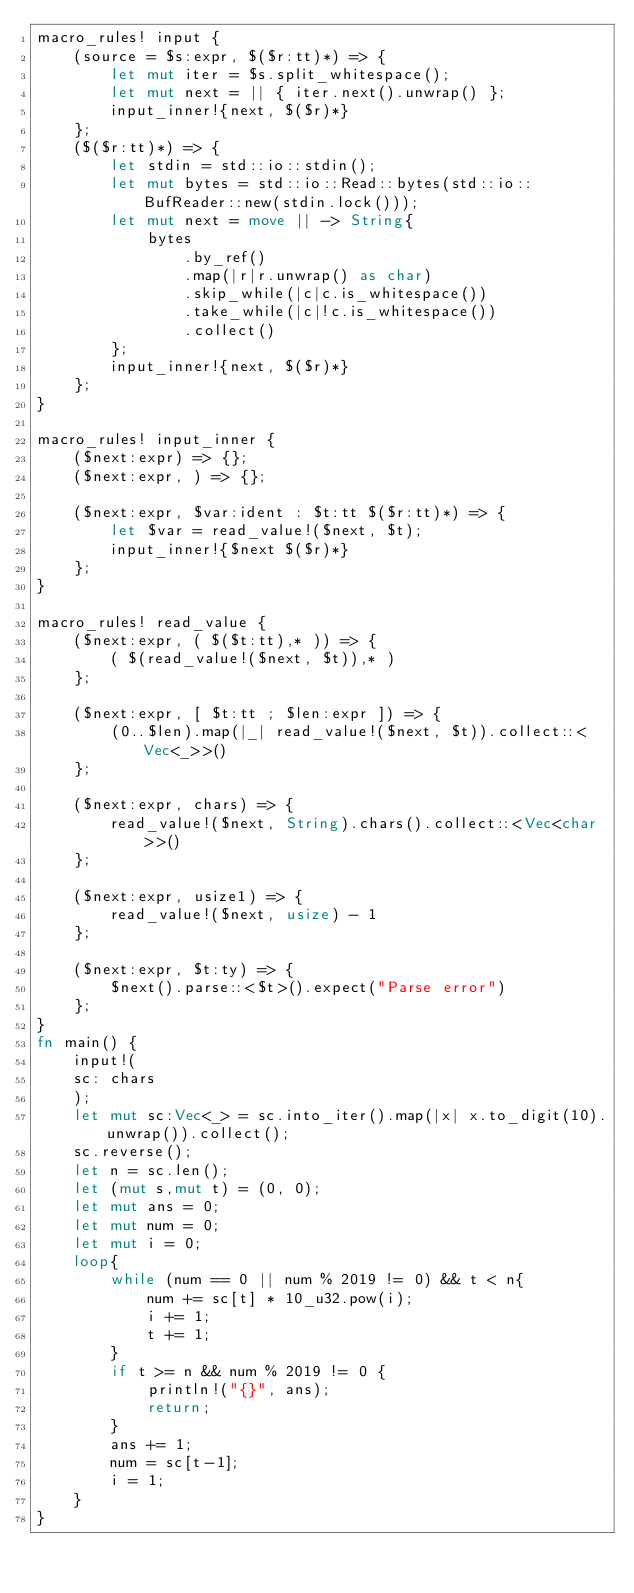Convert code to text. <code><loc_0><loc_0><loc_500><loc_500><_Rust_>macro_rules! input {
    (source = $s:expr, $($r:tt)*) => {
        let mut iter = $s.split_whitespace();
        let mut next = || { iter.next().unwrap() };
        input_inner!{next, $($r)*}
    };
    ($($r:tt)*) => {
        let stdin = std::io::stdin();
        let mut bytes = std::io::Read::bytes(std::io::BufReader::new(stdin.lock()));
        let mut next = move || -> String{
            bytes
                .by_ref()
                .map(|r|r.unwrap() as char)
                .skip_while(|c|c.is_whitespace())
                .take_while(|c|!c.is_whitespace())
                .collect()
        };
        input_inner!{next, $($r)*}
    };
}

macro_rules! input_inner {
    ($next:expr) => {};
    ($next:expr, ) => {};

    ($next:expr, $var:ident : $t:tt $($r:tt)*) => {
        let $var = read_value!($next, $t);
        input_inner!{$next $($r)*}
    };
}

macro_rules! read_value {
    ($next:expr, ( $($t:tt),* )) => {
        ( $(read_value!($next, $t)),* )
    };

    ($next:expr, [ $t:tt ; $len:expr ]) => {
        (0..$len).map(|_| read_value!($next, $t)).collect::<Vec<_>>()
    };

    ($next:expr, chars) => {
        read_value!($next, String).chars().collect::<Vec<char>>()
    };

    ($next:expr, usize1) => {
        read_value!($next, usize) - 1
    };

    ($next:expr, $t:ty) => {
        $next().parse::<$t>().expect("Parse error")
    };
}
fn main() {
    input!(
    sc: chars
    );
    let mut sc:Vec<_> = sc.into_iter().map(|x| x.to_digit(10).unwrap()).collect();
    sc.reverse();
    let n = sc.len();
    let (mut s,mut t) = (0, 0);
    let mut ans = 0;
    let mut num = 0;
    let mut i = 0;
    loop{
        while (num == 0 || num % 2019 != 0) && t < n{
            num += sc[t] * 10_u32.pow(i);
            i += 1;
            t += 1;
        }
        if t >= n && num % 2019 != 0 {
            println!("{}", ans);
            return;
        }
        ans += 1;
        num = sc[t-1];
        i = 1;
    }
}
</code> 